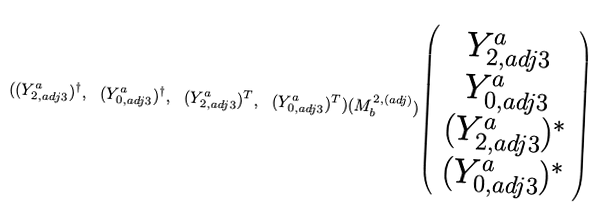Convert formula to latex. <formula><loc_0><loc_0><loc_500><loc_500>( ( Y ^ { a } _ { 2 , a d j 3 } ) ^ { \dagger } , \ ( Y ^ { a } _ { 0 , a d j 3 } ) ^ { \dagger } , \ ( Y ^ { a } _ { 2 , a d j 3 } ) ^ { T } , \ ( Y ^ { a } _ { 0 , a d j 3 } ) ^ { T } ) ( M _ { b } ^ { 2 , ( a d j ) } ) \left ( \begin{array} { c } Y ^ { a } _ { 2 , a d j 3 } \\ Y ^ { a } _ { 0 , a d j 3 } \\ ( Y ^ { a } _ { 2 , a d j 3 } ) ^ { * } \\ ( Y ^ { a } _ { 0 , a d j 3 } ) ^ { * } \end{array} \right )</formula> 